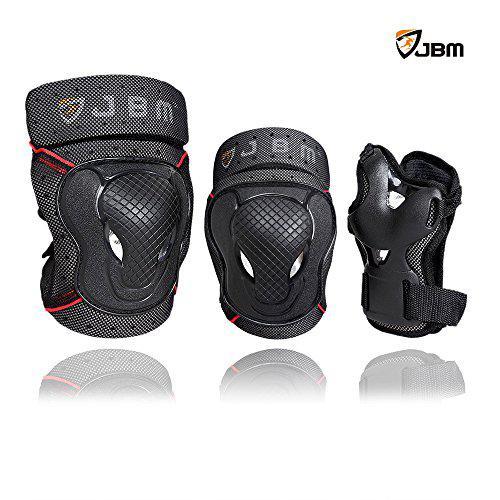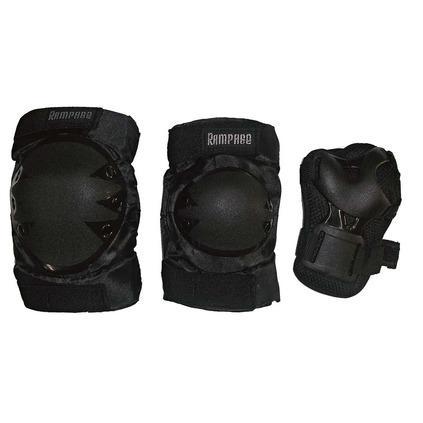The first image is the image on the left, the second image is the image on the right. Considering the images on both sides, is "The image on the right has 3 objects arranged from smallest to largest." valid? Answer yes or no. No. The first image is the image on the left, the second image is the image on the right. Given the left and right images, does the statement "In both images, there are three different types of knee pads in a row." hold true? Answer yes or no. Yes. 